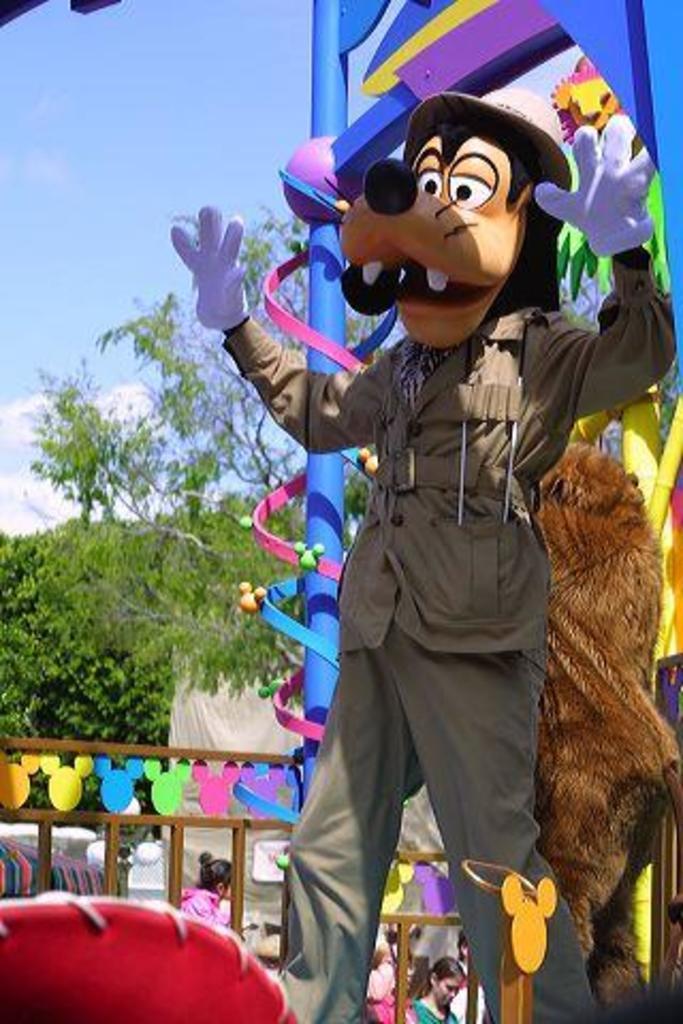Describe this image in one or two sentences. In this image I can see a man wearing a toy mask visible on the right side and I can see a blue color stand visible on the right side and I can see there are few persons at the bottom and trees and fence and I can see the sky at the top. 